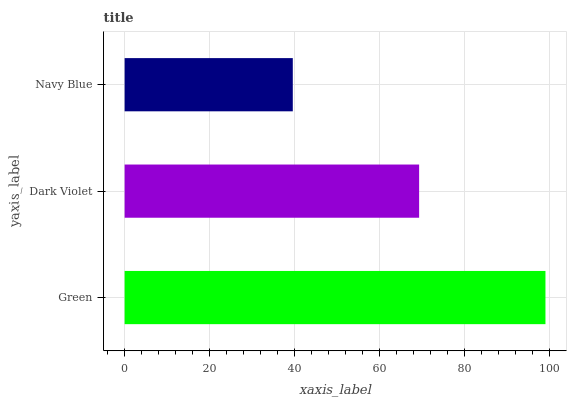Is Navy Blue the minimum?
Answer yes or no. Yes. Is Green the maximum?
Answer yes or no. Yes. Is Dark Violet the minimum?
Answer yes or no. No. Is Dark Violet the maximum?
Answer yes or no. No. Is Green greater than Dark Violet?
Answer yes or no. Yes. Is Dark Violet less than Green?
Answer yes or no. Yes. Is Dark Violet greater than Green?
Answer yes or no. No. Is Green less than Dark Violet?
Answer yes or no. No. Is Dark Violet the high median?
Answer yes or no. Yes. Is Dark Violet the low median?
Answer yes or no. Yes. Is Green the high median?
Answer yes or no. No. Is Navy Blue the low median?
Answer yes or no. No. 